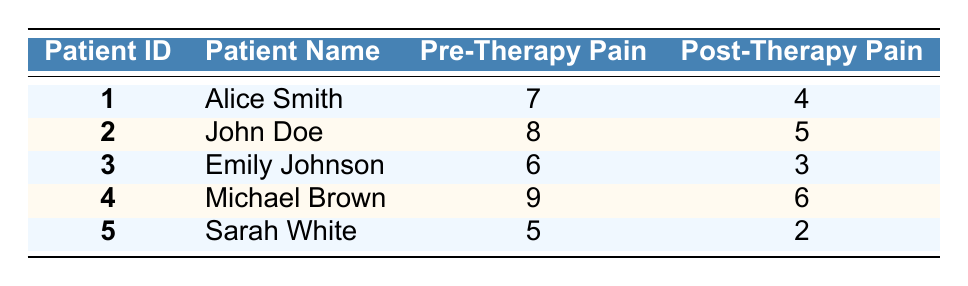What was the self-reported pain level of Emily Johnson before therapy? Referring to the table, Emily Johnson's pre-therapy pain level is directly stated as 6.
Answer: 6 How many patients reported a post-therapy pain level of 4 or lower? By examining the post-therapy pain levels, the patients with values 4 or lower are Alice Smith (4), Emily Johnson (3), Sarah White (2). This gives a total of 3 patients.
Answer: 3 What is the average self-reported pain level before therapy for all patients? The pre-therapy pain levels are 7, 8, 6, 9, and 5. The sum is 35 and there are 5 patients, so the average is 35/5 = 7.
Answer: 7 Is it true that Michael Brown had a higher post-therapy pain level compared to John Doe? Michael Brown's post-therapy pain level is 6, while John Doe's is 5. Therefore, it is true that Michael Brown had a higher post-therapy pain level.
Answer: Yes What is the difference between the highest and lowest post-therapy pain levels? The highest post-therapy pain level is Michael Brown's 6, and the lowest is Sarah White's 2. The difference is 6 - 2 = 4.
Answer: 4 Were there any patients who reported the same pre-therapy and post-therapy pain levels? By checking each patient's pre-therapy and post-therapy values, none of them reported the same level before and after.
Answer: No Which patient had the greatest reduction in pain level after therapy? The pain reduction can be calculated for each patient: Alice Smith (3), John Doe (3), Emily Johnson (3), Michael Brown (3), Sarah White (3). Since all have a reduction of 3, they are tied.
Answer: Tie between all patients What is the sum of self-reported pain levels before therapy for patients who reported a pain level of 6 or more? The patients with pre-therapy pain levels of 6 or more are Alice Smith (7), John Doe (8), Michael Brown (9). Adding those together gives us 7 + 8 + 9 = 24.
Answer: 24 